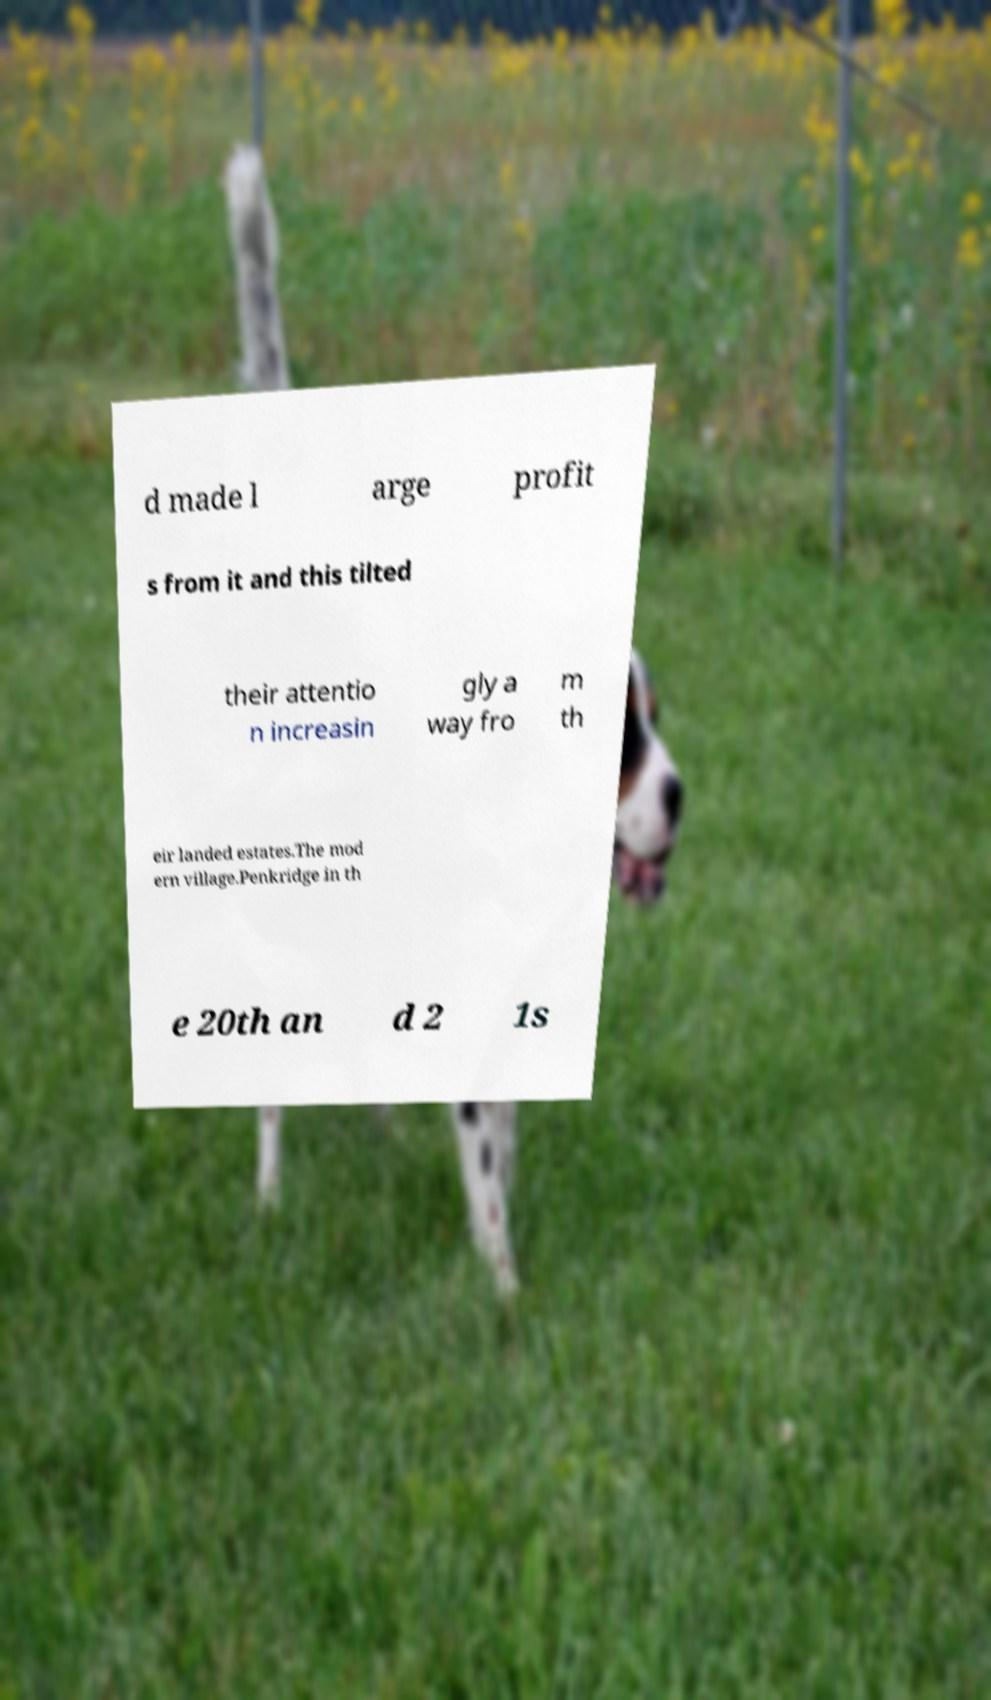Could you assist in decoding the text presented in this image and type it out clearly? d made l arge profit s from it and this tilted their attentio n increasin gly a way fro m th eir landed estates.The mod ern village.Penkridge in th e 20th an d 2 1s 